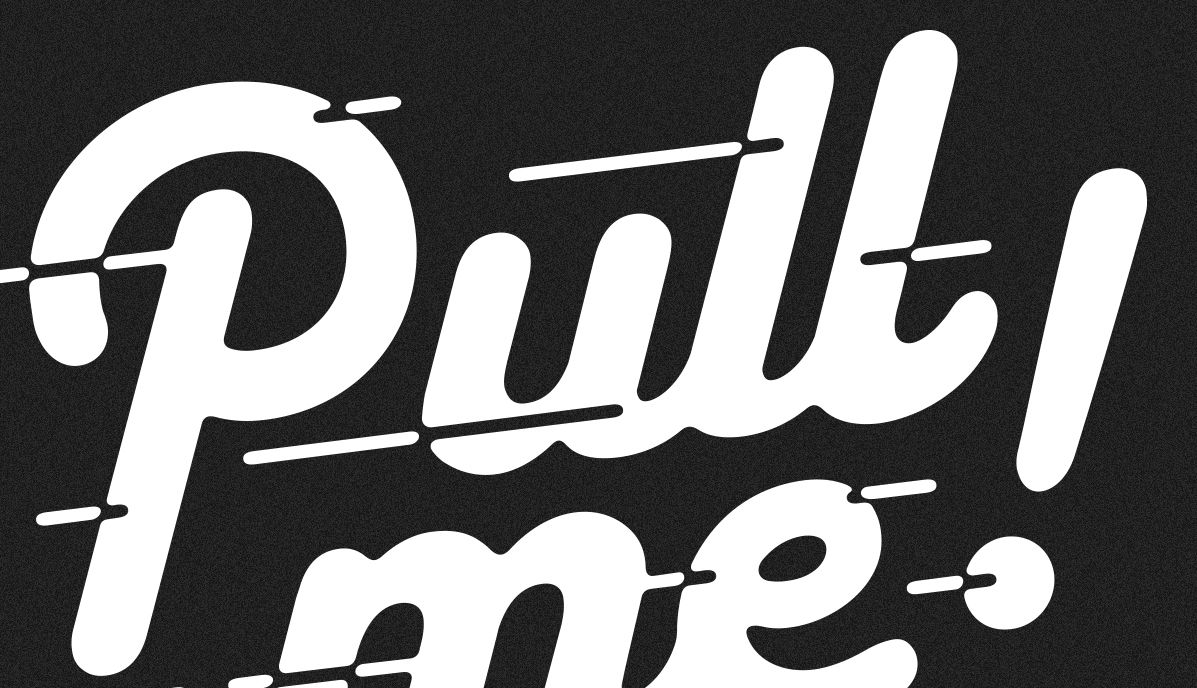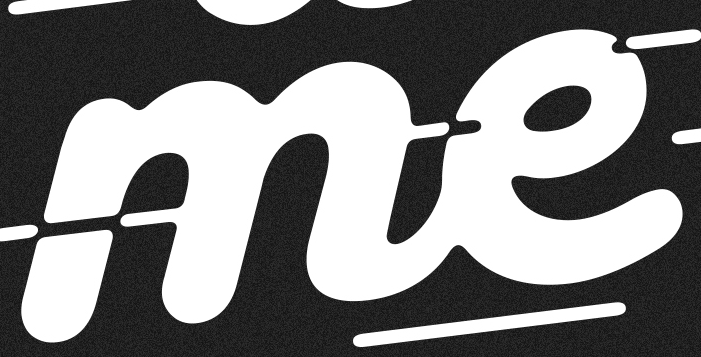What text appears in these images from left to right, separated by a semicolon? pull!; me 